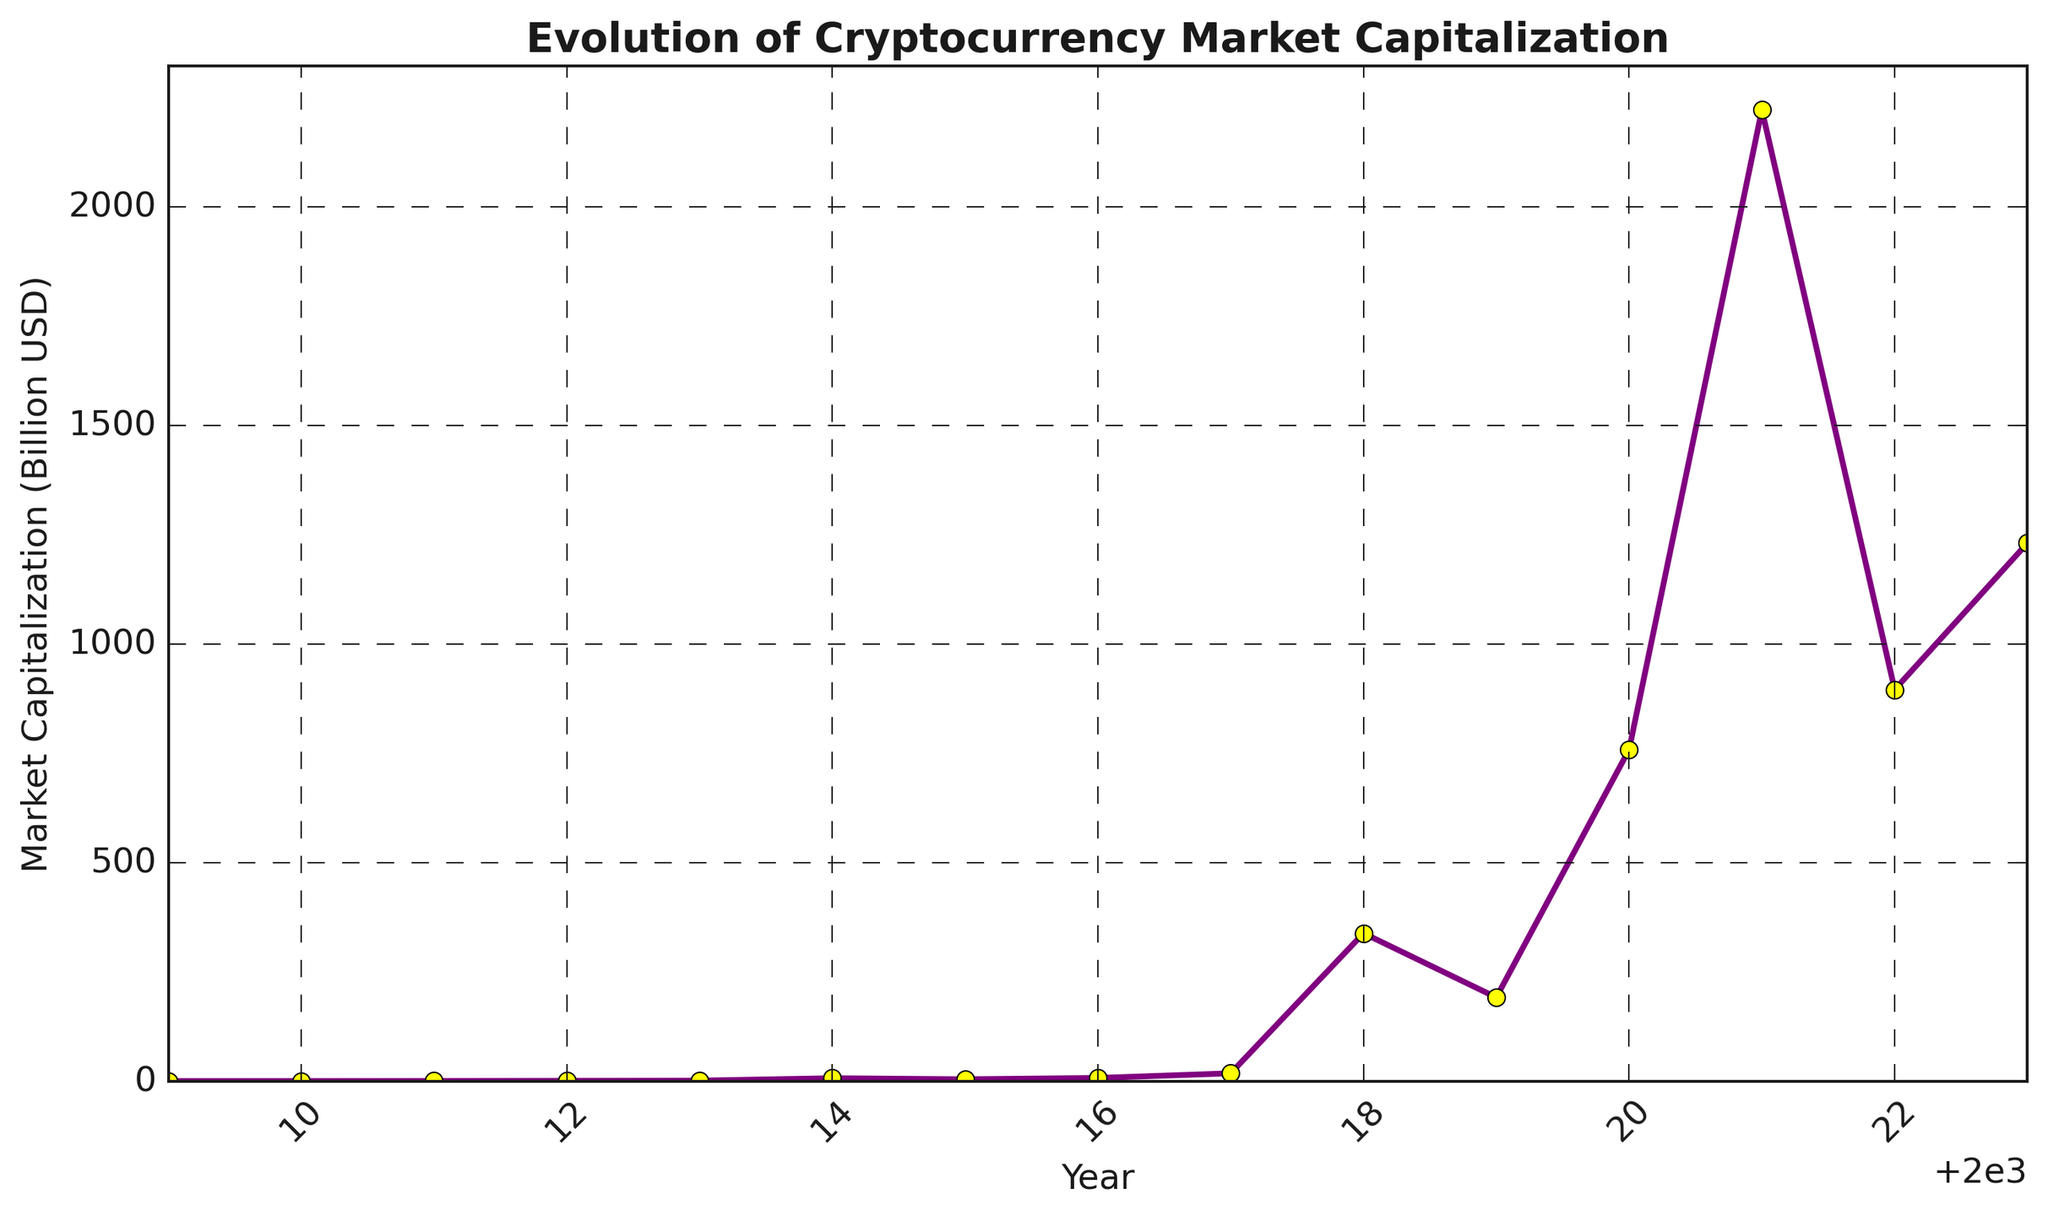What is the maximum market capitalization shown in the figure? The maximum market capitalization can be identified as the highest point on the y-axis. By looking at the plot, the value is recorded in 2021.
Answer: 2221.4 Billion USD In which year was the market capitalization the lowest? To find the lowest market capitalization, observe the point on the y-axis that is nearest to zero. This occurs in 2009.
Answer: 2009 What is the overall trend of the market capitalization from 2009 to 2023? Assess the direction of the line from the start to the end year. The overall trend shows a significant increase, though with some fluctuations.
Answer: Increasing How did market capitalization change from 2017 to 2018? Compare the y-values of the points plotted for 2017 and 2018. There was a major increase from 17.7 Billion USD to 338.1 Billion USD.
Answer: Increased significantly What is the difference in market capitalization between the peak value in 2021 and 2023? Subtract the market capitalization value of 2023 from that of 2021. 2221.4 - 1230.7 = 990.7 Billion USD
Answer: 990.7 Billion USD Which year experienced the highest year-over-year growth in market capitalization? Calculate the yearly growth for each year by subtracting the previous year's value from the current year's value. The highest growth can be seen between 2020 and 2021. 2221.4 - 758.1 = 1463.3 Billion USD
Answer: 2021 What was the market capitalization in 2015, and how does it compare to 2016's value? Look at the plotted values for 2015 and 2016. The 2015 market capitalization was 4.1 Billion USD, which increased to 7.1 Billion USD in 2016.
Answer: 2015: 4.1 Billion USD, 2016: 7.1 Billion USD What is the average market capitalization from 2010 to 2020? Sum the market capitalization values for the years 2010 to 2020 and divide by the number of years (11). (0.03 + 0.13 + 0.5 + 1.0 + 6.5 + 4.1 + 7.1 + 17.7 + 338.1 + 191.3 + 758.1) / 11 = 120.66 Billion USD
Answer: 120.66 Billion USD Which year experienced a decrease in market capitalization from the previous year, and by how much did it decrease? Identify the points where the y-value decreases from one year to the next. This happens between 2014 and 2015. 6.5 - 4.1 = 2.4 Billion USD
Answer: 2015, decreased by 2.4 Billion USD 